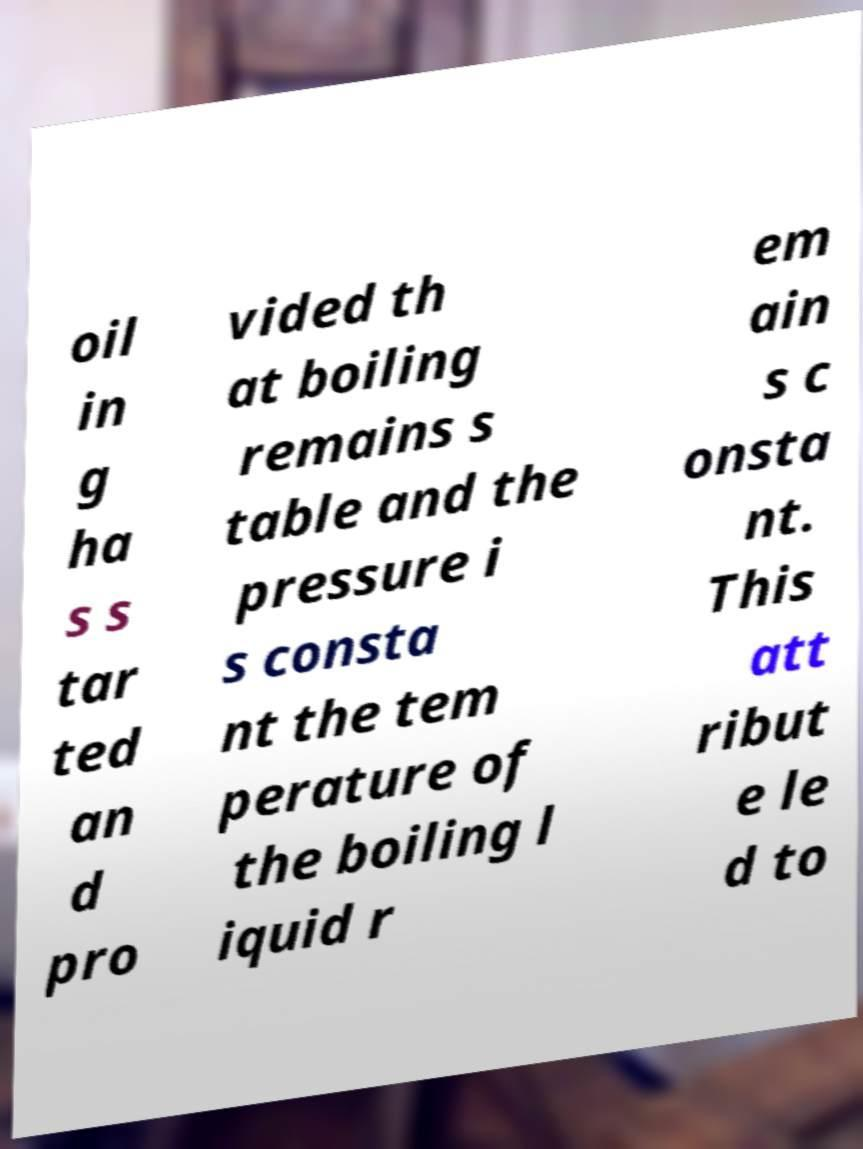Can you accurately transcribe the text from the provided image for me? oil in g ha s s tar ted an d pro vided th at boiling remains s table and the pressure i s consta nt the tem perature of the boiling l iquid r em ain s c onsta nt. This att ribut e le d to 